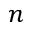<formula> <loc_0><loc_0><loc_500><loc_500>n</formula> 